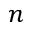<formula> <loc_0><loc_0><loc_500><loc_500>n</formula> 